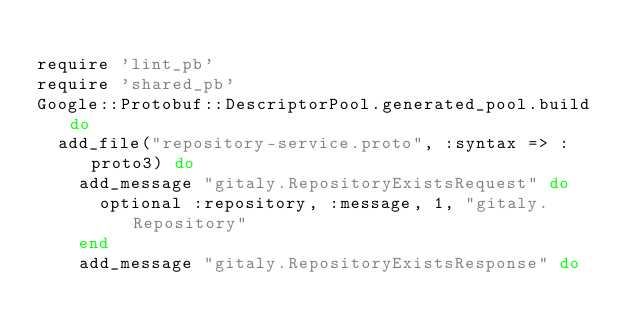<code> <loc_0><loc_0><loc_500><loc_500><_Ruby_>
require 'lint_pb'
require 'shared_pb'
Google::Protobuf::DescriptorPool.generated_pool.build do
  add_file("repository-service.proto", :syntax => :proto3) do
    add_message "gitaly.RepositoryExistsRequest" do
      optional :repository, :message, 1, "gitaly.Repository"
    end
    add_message "gitaly.RepositoryExistsResponse" do</code> 